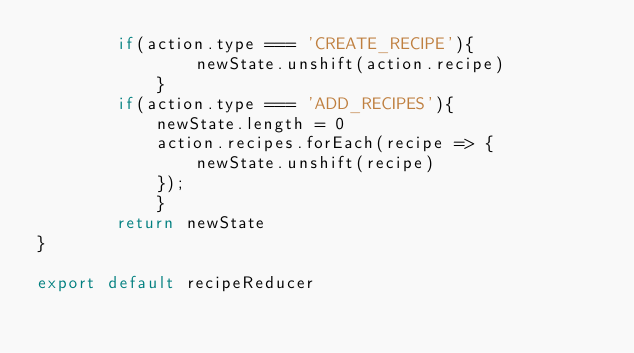Convert code to text. <code><loc_0><loc_0><loc_500><loc_500><_JavaScript_>        if(action.type === 'CREATE_RECIPE'){
                newState.unshift(action.recipe)
            }
        if(action.type === 'ADD_RECIPES'){
            newState.length = 0
            action.recipes.forEach(recipe => {
                newState.unshift(recipe)
            });
            }
        return newState
}

export default recipeReducer</code> 